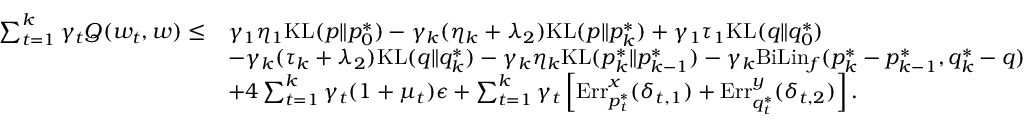<formula> <loc_0><loc_0><loc_500><loc_500>\begin{array} { r l } { \sum _ { t = 1 } ^ { k } \gamma _ { t } Q ( w _ { t } , w ) \leq } & { \gamma _ { 1 } \eta _ { 1 } K L ( p \| p _ { 0 } ^ { * } ) - \gamma _ { k } ( \eta _ { k } + \lambda _ { 2 } ) K L ( p \| p _ { k } ^ { * } ) + \gamma _ { 1 } \tau _ { 1 } K L ( q \| q _ { 0 } ^ { * } ) } \\ & { - \gamma _ { k } ( \tau _ { k } + \lambda _ { 2 } ) K L ( q \| q _ { k } ^ { * } ) - \gamma _ { k } \eta _ { k } K L ( p _ { k } ^ { * } \| p _ { k - 1 } ^ { * } ) - \gamma _ { k } B i L i n _ { f } ( p _ { k } ^ { * } - p _ { k - 1 } ^ { * } , q _ { k } ^ { * } - q ) } \\ & { + 4 \sum _ { t = 1 } ^ { k } \gamma _ { t } ( 1 + \mu _ { t } ) \epsilon + \sum _ { t = 1 } ^ { k } \gamma _ { t } \left [ E r r _ { p _ { t } ^ { * } } ^ { x } ( \delta _ { t , 1 } ) + E r r _ { q _ { t } ^ { * } } ^ { y } ( \delta _ { t , 2 } ) \right ] . } \end{array}</formula> 